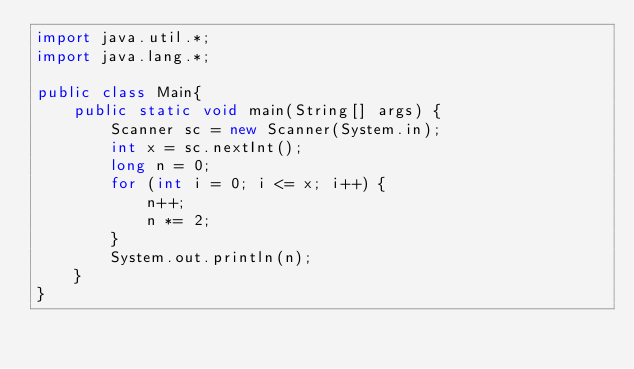<code> <loc_0><loc_0><loc_500><loc_500><_Java_>import java.util.*;
import java.lang.*;

public class Main{
	public static void main(String[] args) {
		Scanner sc = new Scanner(System.in);
		int x = sc.nextInt();
		long n = 0;
		for (int i = 0; i <= x; i++) {
			n++;
			n *= 2;
		}
		System.out.println(n);
	}
}</code> 